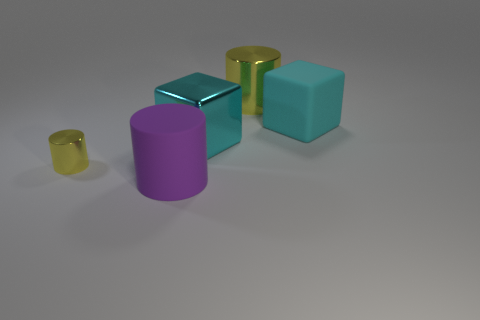Can you describe the different materials present in this image apart from metal? Certainly! Apart from the metallic cube, there are objects that seem to be made from glass, as indicated by their transparency and light refraction, as well as others that appear to be made of a matte plastic due to their lack of reflective properties. 